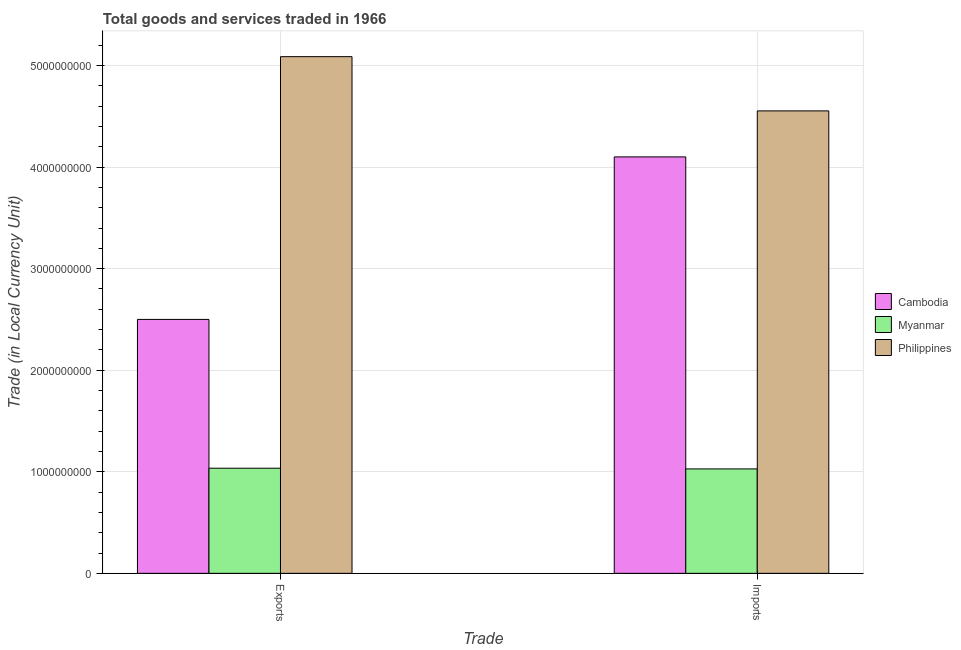How many groups of bars are there?
Provide a short and direct response. 2. Are the number of bars on each tick of the X-axis equal?
Your answer should be compact. Yes. What is the label of the 2nd group of bars from the left?
Offer a terse response. Imports. What is the export of goods and services in Cambodia?
Provide a succinct answer. 2.50e+09. Across all countries, what is the maximum export of goods and services?
Your answer should be very brief. 5.09e+09. Across all countries, what is the minimum imports of goods and services?
Ensure brevity in your answer.  1.03e+09. In which country was the export of goods and services maximum?
Your response must be concise. Philippines. In which country was the imports of goods and services minimum?
Give a very brief answer. Myanmar. What is the total export of goods and services in the graph?
Keep it short and to the point. 8.62e+09. What is the difference between the export of goods and services in Cambodia and that in Myanmar?
Give a very brief answer. 1.46e+09. What is the difference between the export of goods and services in Cambodia and the imports of goods and services in Philippines?
Make the answer very short. -2.05e+09. What is the average export of goods and services per country?
Offer a very short reply. 2.87e+09. What is the difference between the imports of goods and services and export of goods and services in Cambodia?
Your answer should be very brief. 1.60e+09. In how many countries, is the export of goods and services greater than 2000000000 LCU?
Your response must be concise. 2. What is the ratio of the export of goods and services in Philippines to that in Cambodia?
Your answer should be very brief. 2.03. Is the export of goods and services in Philippines less than that in Myanmar?
Offer a terse response. No. In how many countries, is the imports of goods and services greater than the average imports of goods and services taken over all countries?
Give a very brief answer. 2. What is the difference between two consecutive major ticks on the Y-axis?
Make the answer very short. 1.00e+09. Are the values on the major ticks of Y-axis written in scientific E-notation?
Offer a terse response. No. What is the title of the graph?
Your response must be concise. Total goods and services traded in 1966. What is the label or title of the X-axis?
Ensure brevity in your answer.  Trade. What is the label or title of the Y-axis?
Provide a short and direct response. Trade (in Local Currency Unit). What is the Trade (in Local Currency Unit) in Cambodia in Exports?
Offer a terse response. 2.50e+09. What is the Trade (in Local Currency Unit) of Myanmar in Exports?
Ensure brevity in your answer.  1.04e+09. What is the Trade (in Local Currency Unit) in Philippines in Exports?
Provide a short and direct response. 5.09e+09. What is the Trade (in Local Currency Unit) of Cambodia in Imports?
Provide a succinct answer. 4.10e+09. What is the Trade (in Local Currency Unit) of Myanmar in Imports?
Keep it short and to the point. 1.03e+09. What is the Trade (in Local Currency Unit) of Philippines in Imports?
Your response must be concise. 4.55e+09. Across all Trade, what is the maximum Trade (in Local Currency Unit) of Cambodia?
Your response must be concise. 4.10e+09. Across all Trade, what is the maximum Trade (in Local Currency Unit) of Myanmar?
Your response must be concise. 1.04e+09. Across all Trade, what is the maximum Trade (in Local Currency Unit) in Philippines?
Give a very brief answer. 5.09e+09. Across all Trade, what is the minimum Trade (in Local Currency Unit) of Cambodia?
Provide a short and direct response. 2.50e+09. Across all Trade, what is the minimum Trade (in Local Currency Unit) of Myanmar?
Offer a terse response. 1.03e+09. Across all Trade, what is the minimum Trade (in Local Currency Unit) of Philippines?
Your answer should be compact. 4.55e+09. What is the total Trade (in Local Currency Unit) of Cambodia in the graph?
Keep it short and to the point. 6.60e+09. What is the total Trade (in Local Currency Unit) of Myanmar in the graph?
Keep it short and to the point. 2.06e+09. What is the total Trade (in Local Currency Unit) in Philippines in the graph?
Provide a short and direct response. 9.64e+09. What is the difference between the Trade (in Local Currency Unit) in Cambodia in Exports and that in Imports?
Your response must be concise. -1.60e+09. What is the difference between the Trade (in Local Currency Unit) in Myanmar in Exports and that in Imports?
Give a very brief answer. 7.00e+06. What is the difference between the Trade (in Local Currency Unit) of Philippines in Exports and that in Imports?
Keep it short and to the point. 5.34e+08. What is the difference between the Trade (in Local Currency Unit) of Cambodia in Exports and the Trade (in Local Currency Unit) of Myanmar in Imports?
Your answer should be compact. 1.47e+09. What is the difference between the Trade (in Local Currency Unit) of Cambodia in Exports and the Trade (in Local Currency Unit) of Philippines in Imports?
Make the answer very short. -2.05e+09. What is the difference between the Trade (in Local Currency Unit) in Myanmar in Exports and the Trade (in Local Currency Unit) in Philippines in Imports?
Your response must be concise. -3.52e+09. What is the average Trade (in Local Currency Unit) of Cambodia per Trade?
Your response must be concise. 3.30e+09. What is the average Trade (in Local Currency Unit) of Myanmar per Trade?
Give a very brief answer. 1.03e+09. What is the average Trade (in Local Currency Unit) in Philippines per Trade?
Keep it short and to the point. 4.82e+09. What is the difference between the Trade (in Local Currency Unit) of Cambodia and Trade (in Local Currency Unit) of Myanmar in Exports?
Make the answer very short. 1.46e+09. What is the difference between the Trade (in Local Currency Unit) of Cambodia and Trade (in Local Currency Unit) of Philippines in Exports?
Your answer should be compact. -2.59e+09. What is the difference between the Trade (in Local Currency Unit) of Myanmar and Trade (in Local Currency Unit) of Philippines in Exports?
Provide a succinct answer. -4.05e+09. What is the difference between the Trade (in Local Currency Unit) of Cambodia and Trade (in Local Currency Unit) of Myanmar in Imports?
Provide a succinct answer. 3.07e+09. What is the difference between the Trade (in Local Currency Unit) in Cambodia and Trade (in Local Currency Unit) in Philippines in Imports?
Provide a succinct answer. -4.53e+08. What is the difference between the Trade (in Local Currency Unit) of Myanmar and Trade (in Local Currency Unit) of Philippines in Imports?
Ensure brevity in your answer.  -3.52e+09. What is the ratio of the Trade (in Local Currency Unit) of Cambodia in Exports to that in Imports?
Your answer should be very brief. 0.61. What is the ratio of the Trade (in Local Currency Unit) of Myanmar in Exports to that in Imports?
Your answer should be very brief. 1.01. What is the ratio of the Trade (in Local Currency Unit) in Philippines in Exports to that in Imports?
Your answer should be compact. 1.12. What is the difference between the highest and the second highest Trade (in Local Currency Unit) of Cambodia?
Give a very brief answer. 1.60e+09. What is the difference between the highest and the second highest Trade (in Local Currency Unit) of Myanmar?
Keep it short and to the point. 7.00e+06. What is the difference between the highest and the second highest Trade (in Local Currency Unit) in Philippines?
Your answer should be compact. 5.34e+08. What is the difference between the highest and the lowest Trade (in Local Currency Unit) of Cambodia?
Keep it short and to the point. 1.60e+09. What is the difference between the highest and the lowest Trade (in Local Currency Unit) of Myanmar?
Your answer should be very brief. 7.00e+06. What is the difference between the highest and the lowest Trade (in Local Currency Unit) of Philippines?
Your answer should be very brief. 5.34e+08. 